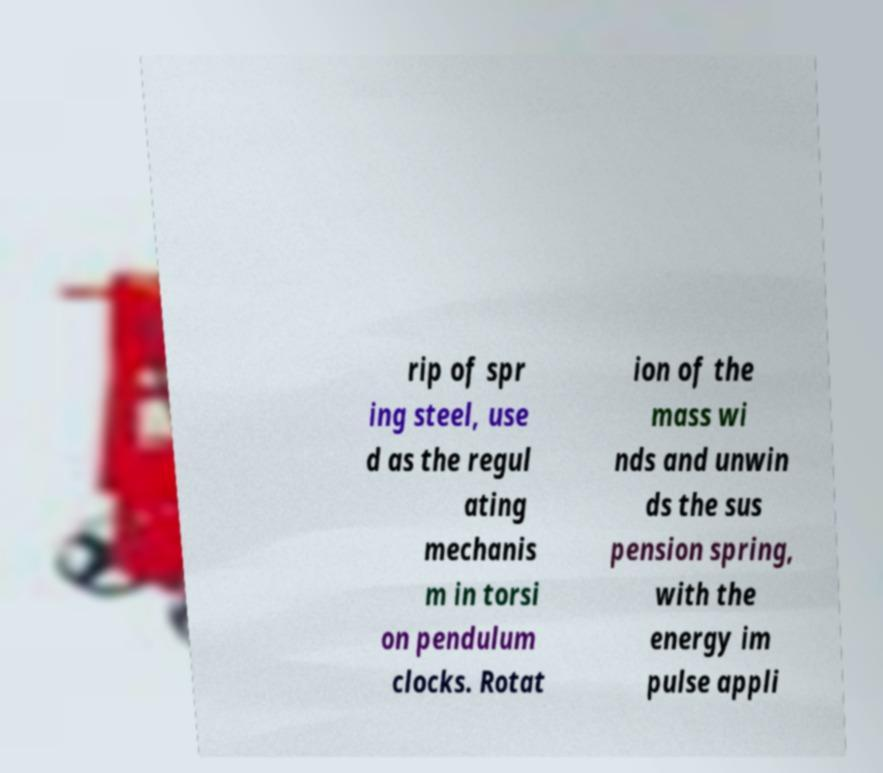Could you assist in decoding the text presented in this image and type it out clearly? rip of spr ing steel, use d as the regul ating mechanis m in torsi on pendulum clocks. Rotat ion of the mass wi nds and unwin ds the sus pension spring, with the energy im pulse appli 